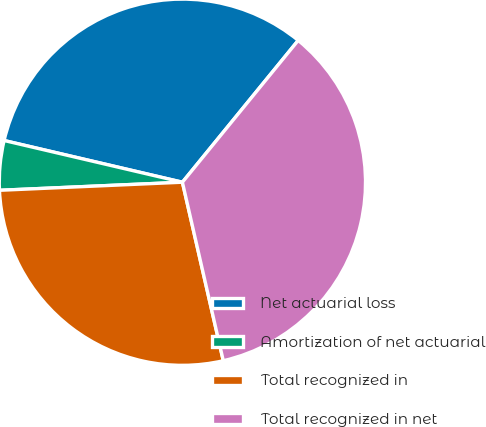<chart> <loc_0><loc_0><loc_500><loc_500><pie_chart><fcel>Net actuarial loss<fcel>Amortization of net actuarial<fcel>Total recognized in<fcel>Total recognized in net<nl><fcel>32.24%<fcel>4.36%<fcel>27.88%<fcel>35.52%<nl></chart> 